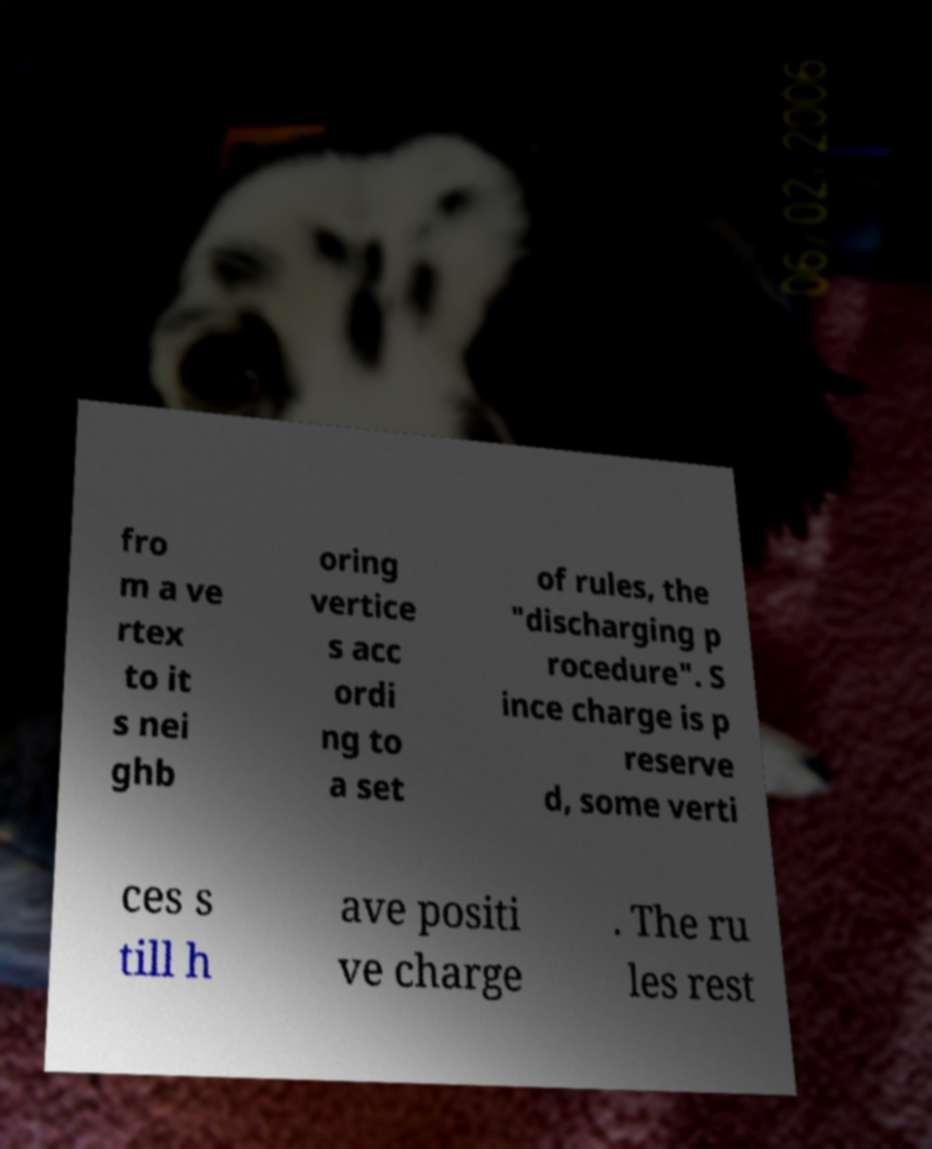Please read and relay the text visible in this image. What does it say? fro m a ve rtex to it s nei ghb oring vertice s acc ordi ng to a set of rules, the "discharging p rocedure". S ince charge is p reserve d, some verti ces s till h ave positi ve charge . The ru les rest 